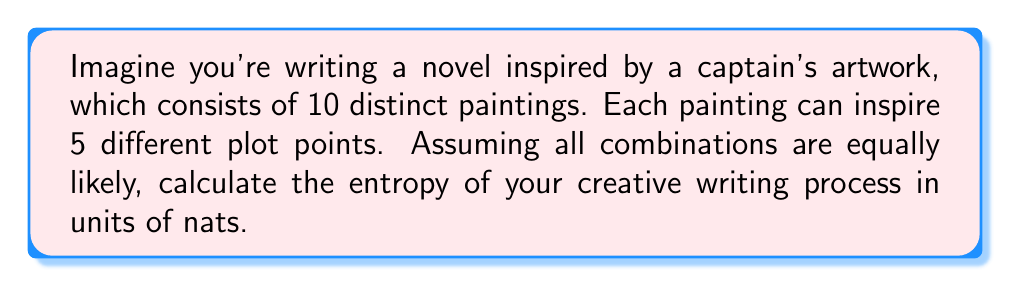Provide a solution to this math problem. Let's approach this step-by-step:

1) First, we need to determine the total number of possible outcomes. In this case, it's the number of ways to choose plot points from the paintings:

   Total outcomes = $5^{10}$ (5 choices for each of the 10 paintings)

2) The probability of each outcome, assuming they are equally likely, is:

   $p = \frac{1}{5^{10}}$

3) The entropy formula in nats is:

   $S = -\sum_{i=1}^{N} p_i \ln(p_i)$

   Where $N$ is the total number of outcomes and $p_i$ is the probability of each outcome.

4) Since all probabilities are equal, we can simplify:

   $S = -N \cdot p \ln(p)$

5) Substituting our values:

   $S = -5^{10} \cdot \frac{1}{5^{10}} \ln(\frac{1}{5^{10}})$

6) Simplify:

   $S = -\ln(\frac{1}{5^{10}}) = \ln(5^{10}) = 10 \ln(5)$

7) Calculate:

   $S = 10 \cdot 1.60944 \approx 16.0944$ nats
Answer: $16.0944$ nats 